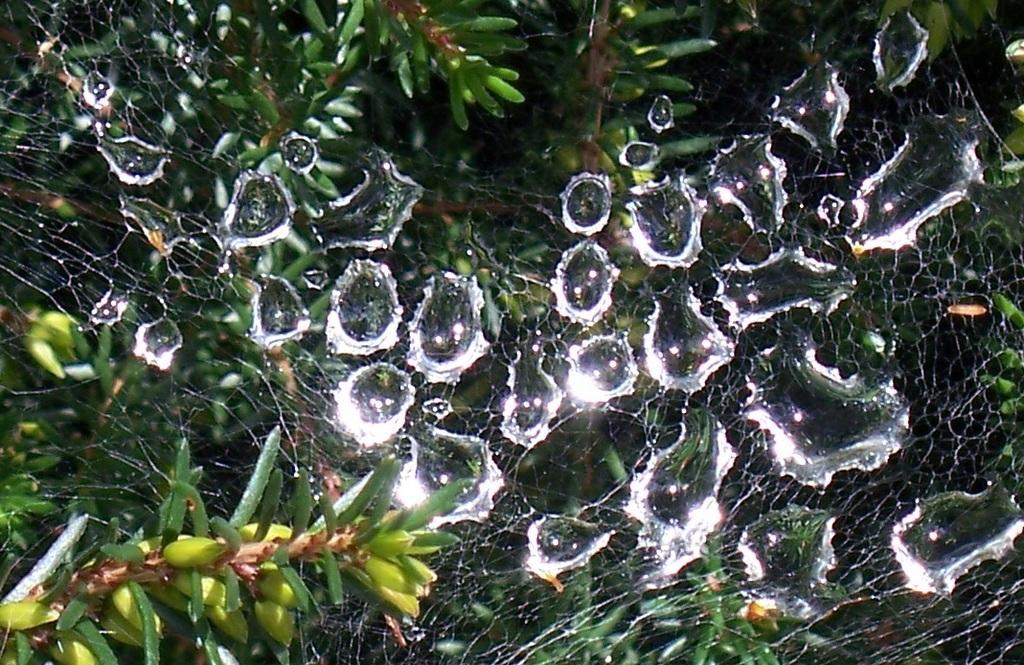Describe this image in one or two sentences. In this image I can see the spider web in-between the plants. And there are some water droplets on the spider web. 